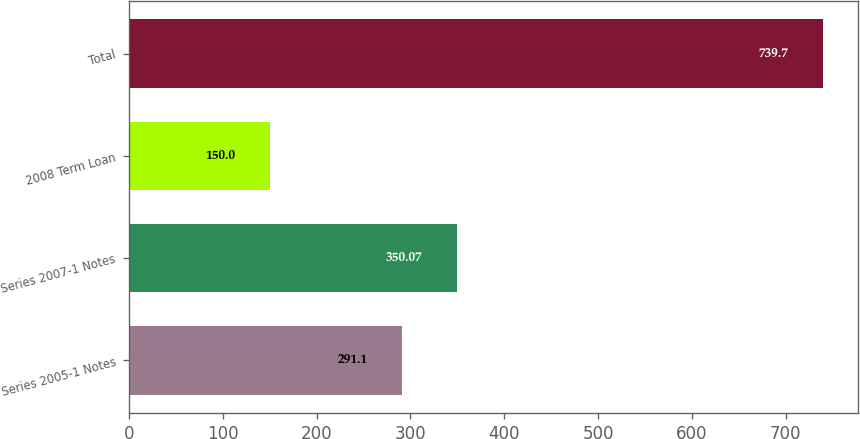Convert chart to OTSL. <chart><loc_0><loc_0><loc_500><loc_500><bar_chart><fcel>Series 2005-1 Notes<fcel>Series 2007-1 Notes<fcel>2008 Term Loan<fcel>Total<nl><fcel>291.1<fcel>350.07<fcel>150<fcel>739.7<nl></chart> 